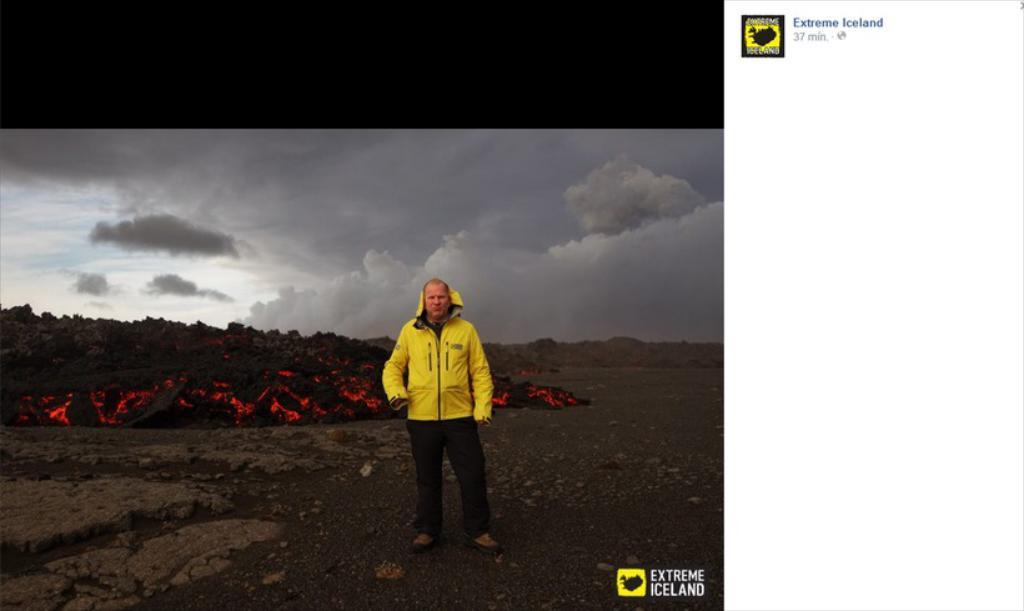Please provide a concise description of this image. This is an edited image. In this image we can see a man standing on the ground. We can also see some stones, the mountain with lava, the hills and the sky which looks cloudy. On the right side we can see a logo and some text. 